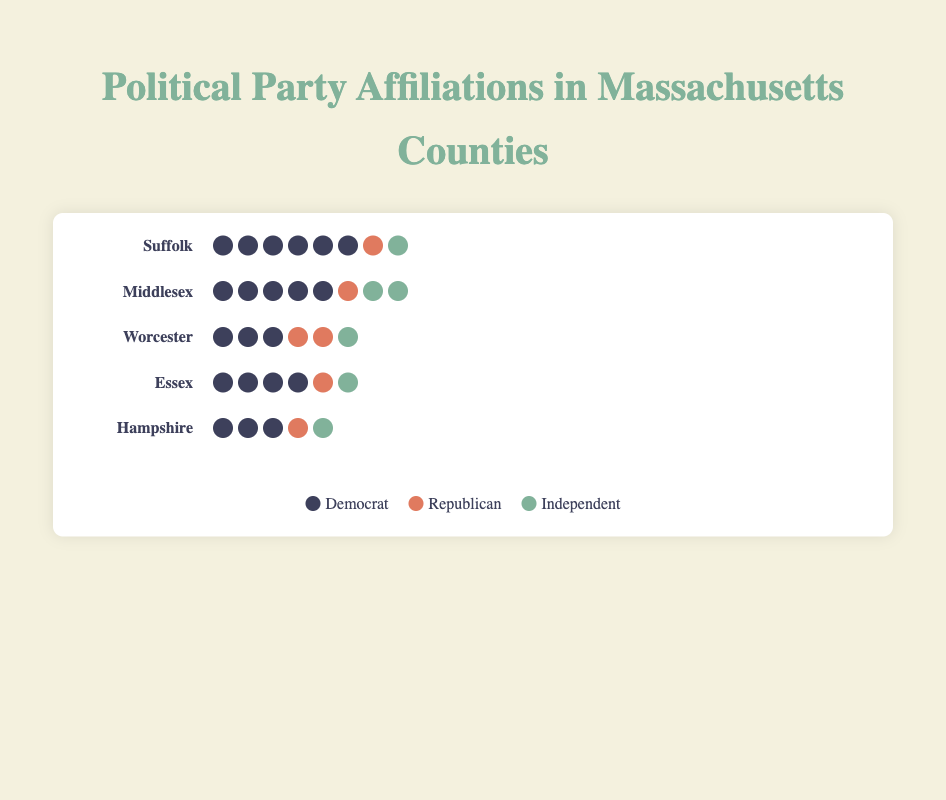Which county has the highest number of Democrats? The figure shows that Suffolk has the most Democrat icons, totaling 30.
Answer: Suffolk How many total party affiliations are represented in Middlesex? Middlesex's party affiliations are 25 Democrats, 7 Republicans, and 8 Independents. Totaling these numbers is 25 + 7 + 8 = 40.
Answer: 40 Which party is most common in Worcester, and how many people are affiliated with it? The democrat party has the highest representation in Worcester with 18 members.
Answer: Democrat, 18 How does the number of Independents in Essex compare to that in Hampshire? The figure shows both Essex and Hampshire have 7 Independents each, making them equal.
Answer: Equal, 7 What is the combined number of Republicans in Suffolk and Essex? Suffolk has 4 Republicans and Essex has 8 Republicans. Combined, this is 4 + 8 = 12.
Answer: 12 Is the number of Democrats in Middlesex more than the total number of Republicans and Independents combined in Middlesex? Sum the Republicans and Independents in Middlesex (7 + 8 = 15), and compare it with the Democrats (25). 25 is greater than 15.
Answer: Yes Which county has the smallest number of Independents, and what is the number? The figure shows that both Hampshire and Worcester have the smallest number of Independents, each with 5.
Answer: Hampshire and Worcester, 5 What is the total number of party affiliations represented across all counties? Sum the total representations of all parties from each county: 40 (Suffolk) + 40 (Middlesex) + 35 (Worcester) + 35 (Essex) + 25 (Hampshire) = 175.
Answer: 175 How does the representation of Republicans in Worcester compare to that in Middlesex? Worcester has 10 Republicans, while Middlesex has 7 Republicans. Thus, Worcester has 3 more Republicans than Middlesex.
Answer: Worcester, 3 more Which county has the most balanced representation among the three parties, and what are the proportions? Hampshire has the most balanced representation with 15 Democrats, 5 Republicans, and 5 Independents, making the proportions 3:1:1.
Answer: Hampshire, 3:1:1 